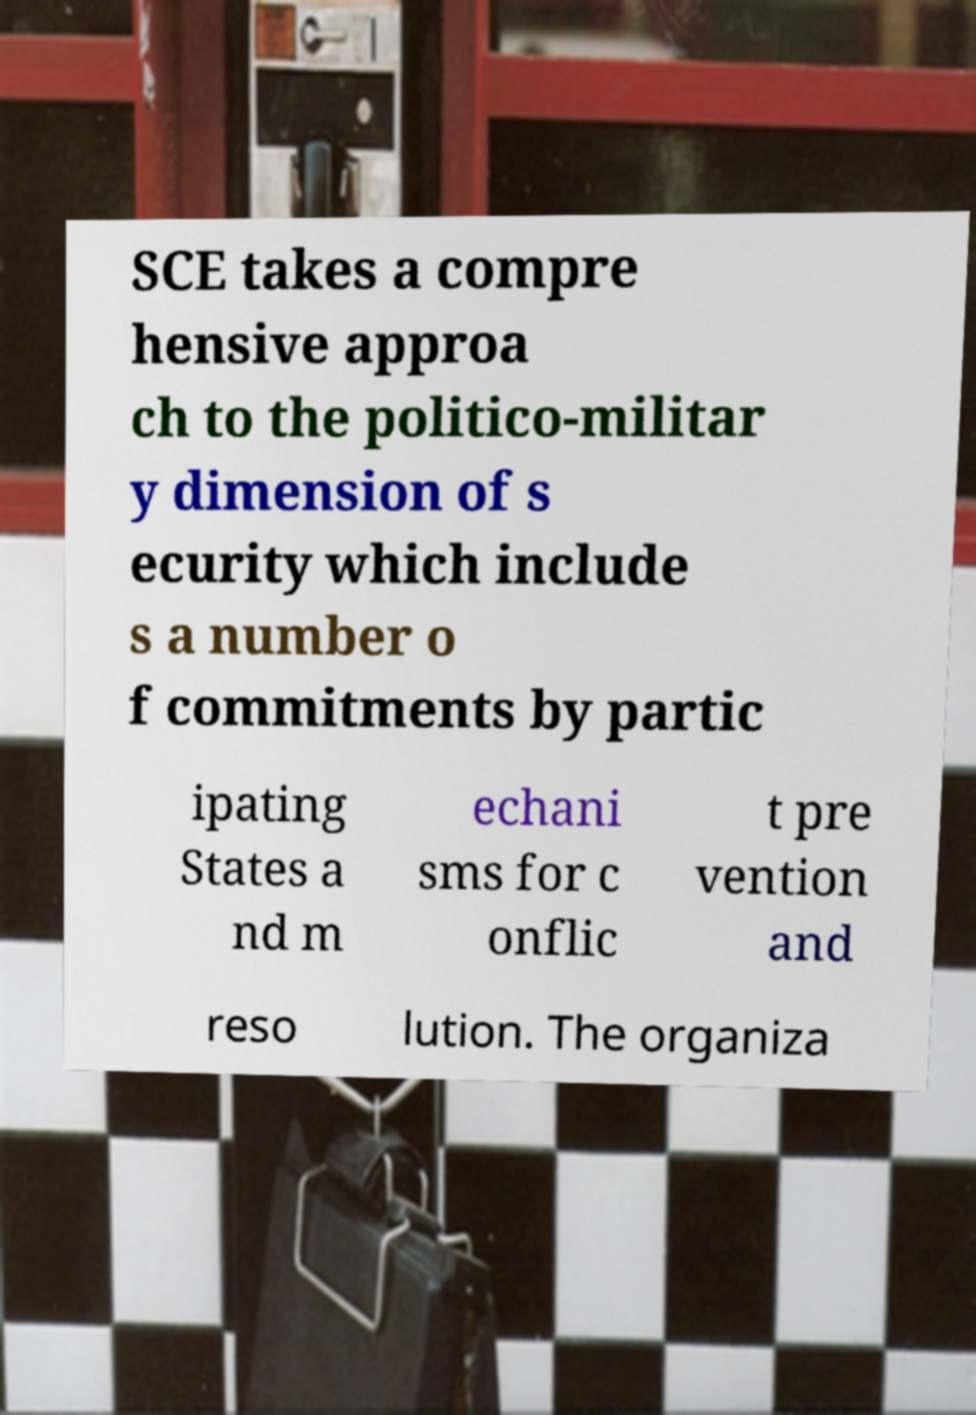For documentation purposes, I need the text within this image transcribed. Could you provide that? SCE takes a compre hensive approa ch to the politico-militar y dimension of s ecurity which include s a number o f commitments by partic ipating States a nd m echani sms for c onflic t pre vention and reso lution. The organiza 